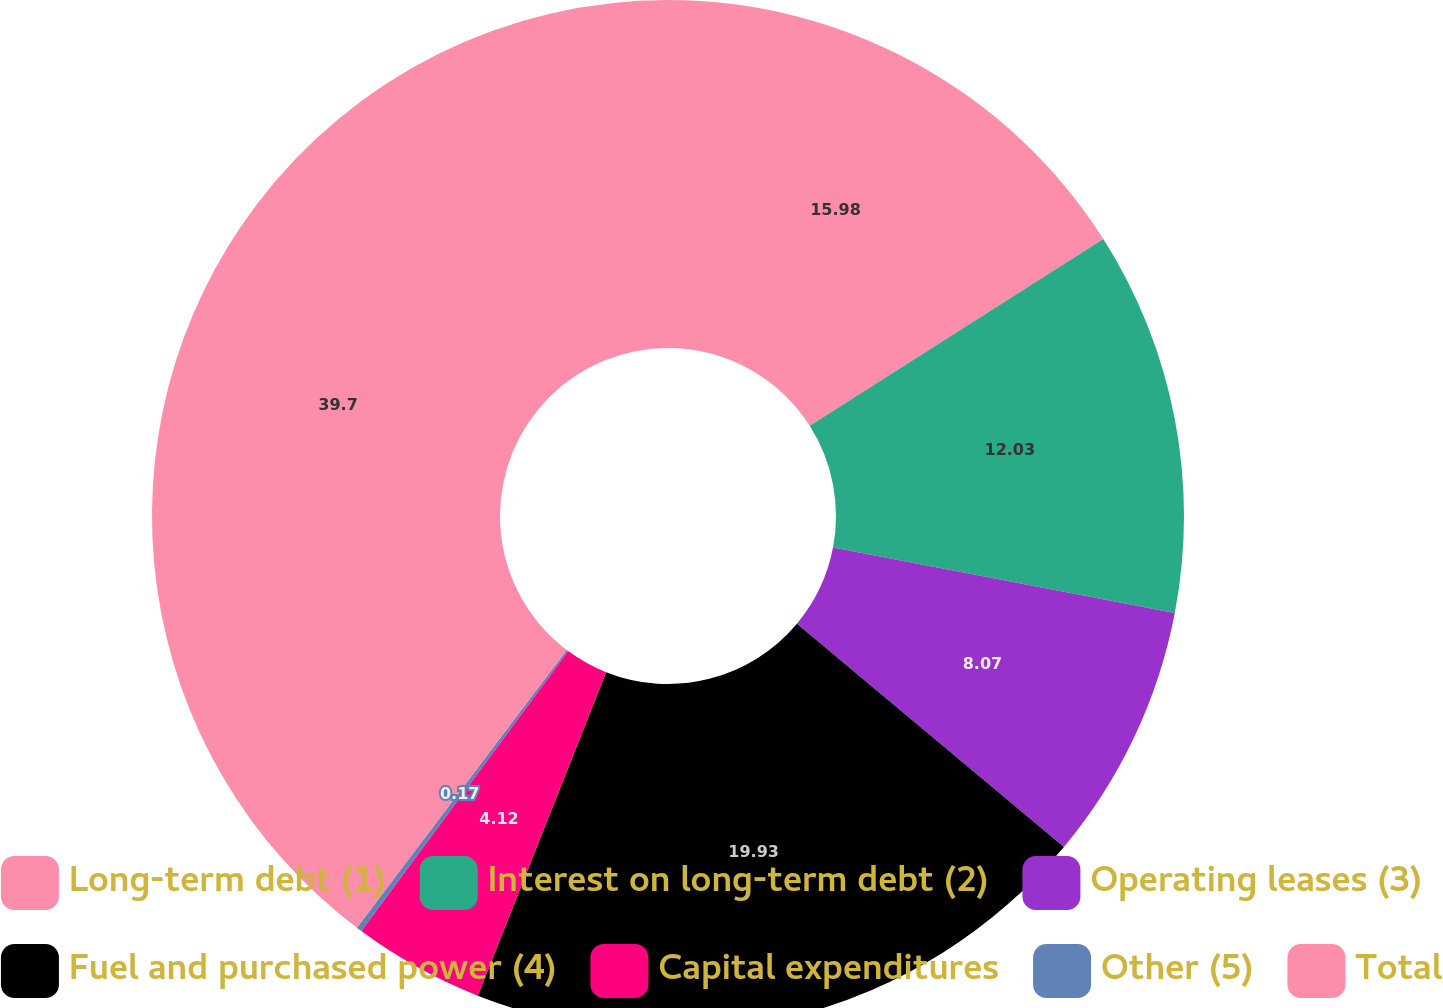<chart> <loc_0><loc_0><loc_500><loc_500><pie_chart><fcel>Long-term debt (1)<fcel>Interest on long-term debt (2)<fcel>Operating leases (3)<fcel>Fuel and purchased power (4)<fcel>Capital expenditures<fcel>Other (5)<fcel>Total<nl><fcel>15.98%<fcel>12.03%<fcel>8.07%<fcel>19.93%<fcel>4.12%<fcel>0.17%<fcel>39.7%<nl></chart> 